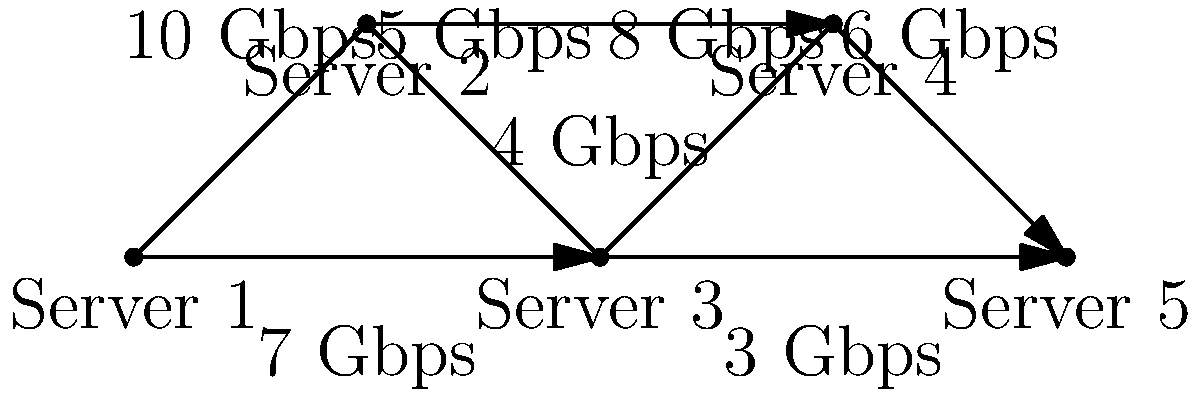Given the network topology for a media streaming infrastructure shown above, what is the maximum sustainable throughput (in Gbps) for streaming content from Server 1 to Server 5, assuming each server can relay the stream without bottlenecks? To solve this problem, we need to find the path with the highest minimum bandwidth from Server 1 to Server 5. Let's break it down step-by-step:

1. Identify all possible paths from Server 1 to Server 5:
   Path 1: 1 → 2 → 3 → 4 → 5
   Path 2: 1 → 2 → 5
   Path 3: 1 → 3 → 4 → 5

2. Calculate the minimum bandwidth for each path:
   Path 1: min(10, 5, 8, 6) = 5 Gbps
   Path 2: min(10, 7) = 7 Gbps
   Path 3: min(4, 8, 6) = 4 Gbps

3. Choose the path with the highest minimum bandwidth:
   The highest minimum bandwidth is 7 Gbps, which corresponds to Path 2.

4. Therefore, the maximum sustainable throughput for streaming content from Server 1 to Server 5 is 7 Gbps.

This solution assumes that each server can relay the stream without introducing additional bottlenecks, as stated in the question. In a real-world scenario, factors such as server processing capacity, storage I/O, and network interface capabilities would also need to be considered.
Answer: 7 Gbps 